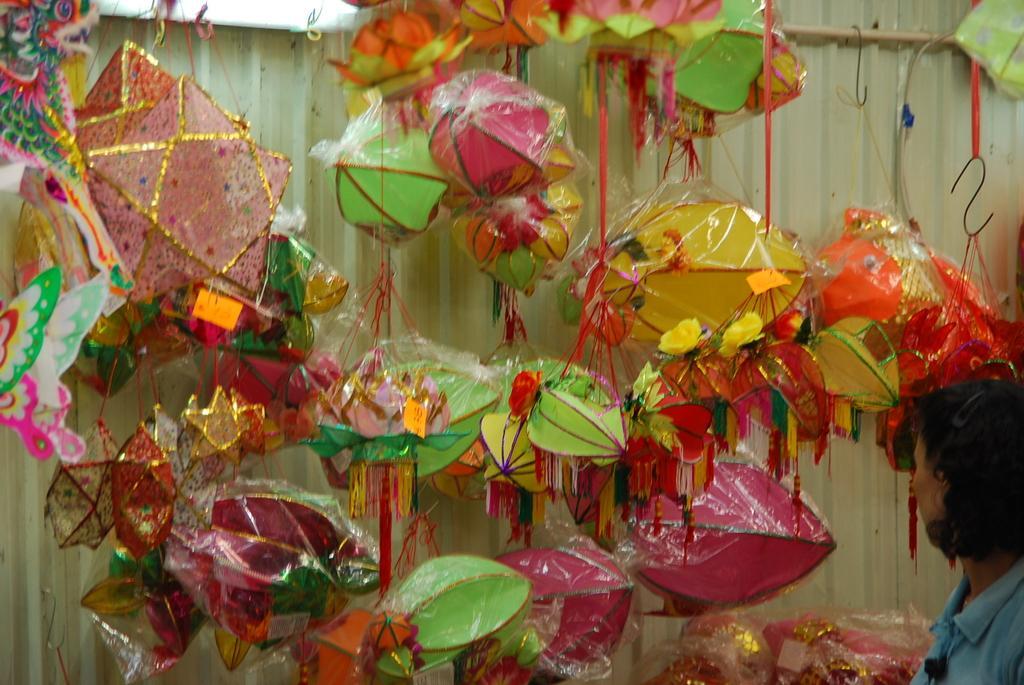In one or two sentences, can you explain what this image depicts? This picture shows few lanterns in the covers hanging to the hooks and we see a woman standing and looking at them. 